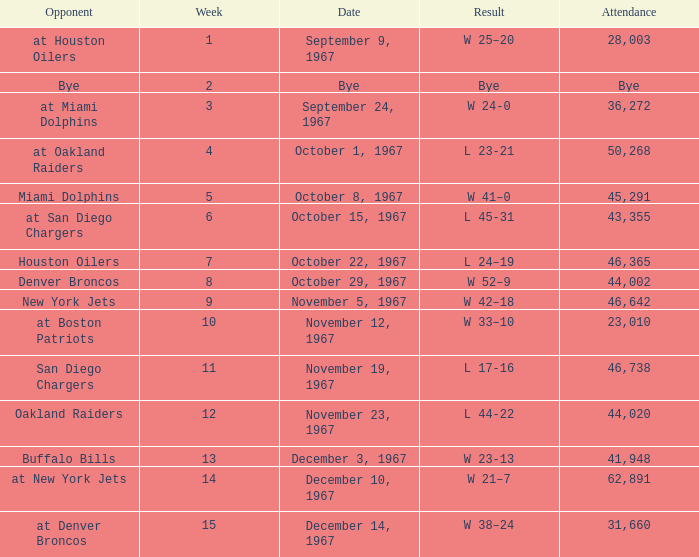Who was the opponent after week 9 with an attendance of 44,020? Oakland Raiders. 